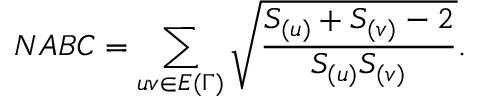<formula> <loc_0><loc_0><loc_500><loc_500>N A B C = \sum _ { u v \in E { ( \Gamma ) } } \sqrt { \frac { S _ { ( u ) } + S _ { ( v ) } - 2 } { S _ { ( u ) } S _ { ( v ) } } } .</formula> 